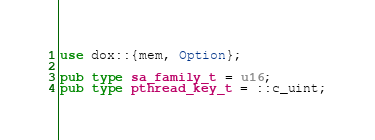Convert code to text. <code><loc_0><loc_0><loc_500><loc_500><_Rust_>use dox::{mem, Option};

pub type sa_family_t = u16;
pub type pthread_key_t = ::c_uint;</code> 